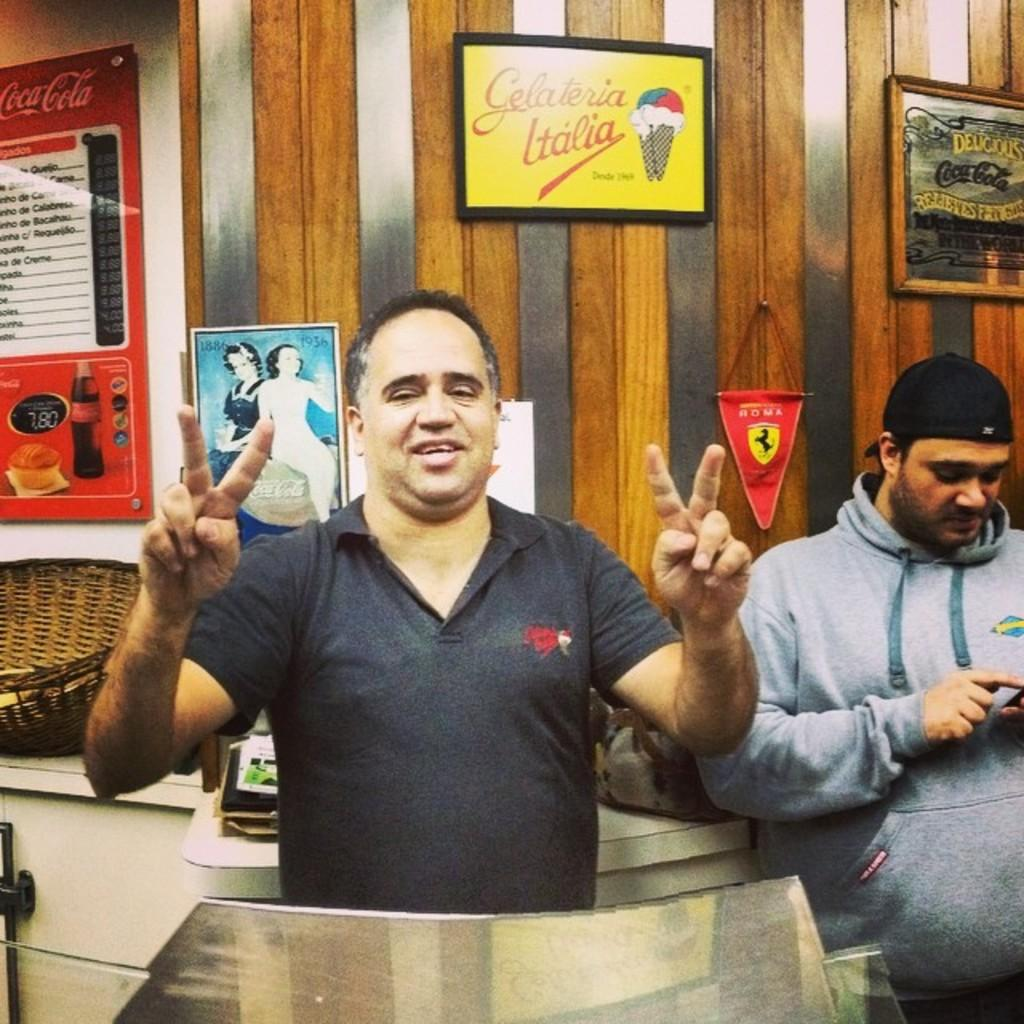How many people are in the image? There are two people in the image. Can you describe the clothing of one of the individuals? One person is wearing a black color cap. What can be seen in the background of the image? There is a wall with some boards visible in the background. What else is present in the image besides the people and the wall? There are other objects on a table in the image. What type of powder is being used by the person wearing the black color cap in the image? There is no indication of any powder being used in the image. What news event is being discussed by the two people in the image? There is no conversation or news event visible in the image. 